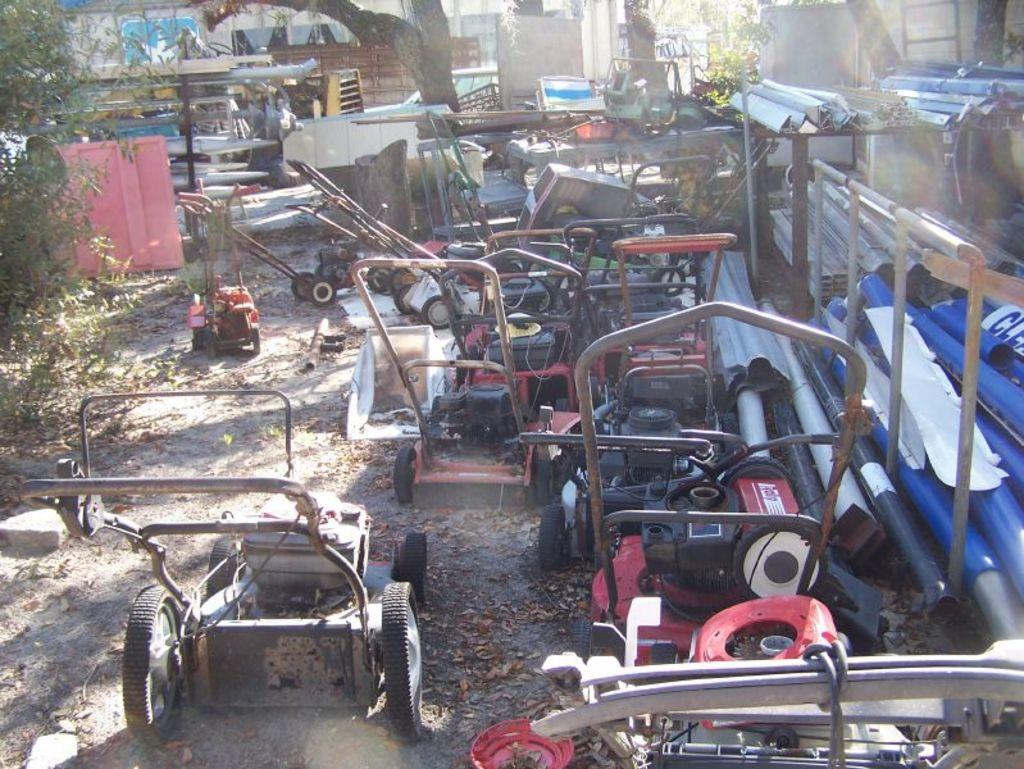What is located in the center of the image? There are trolley machines, pipes, rods, and a ladder in the center of the image. What type of vegetation can be seen in the image? There are trees in the image. What type of structure is present in the image? There is a shed in the image. What is visible at the bottom of the image? Dry leaves, the ground, and rocks are present at the bottom of the image. What is the value of the kitty in the image? There is no kitty present in the image, so it is not possible to determine its value. What type of government is depicted in the image? There is no reference to any government in the image. 